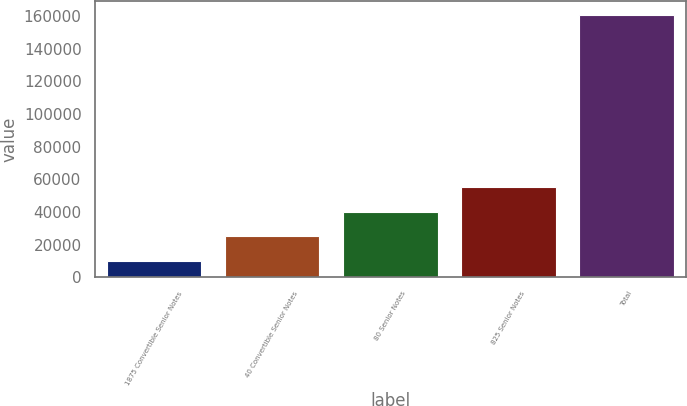Convert chart. <chart><loc_0><loc_0><loc_500><loc_500><bar_chart><fcel>1875 Convertible Senior Notes<fcel>40 Convertible Senior Notes<fcel>80 Senior Notes<fcel>825 Senior Notes<fcel>Total<nl><fcel>10090<fcel>25170.6<fcel>40251.2<fcel>55331.8<fcel>160896<nl></chart> 